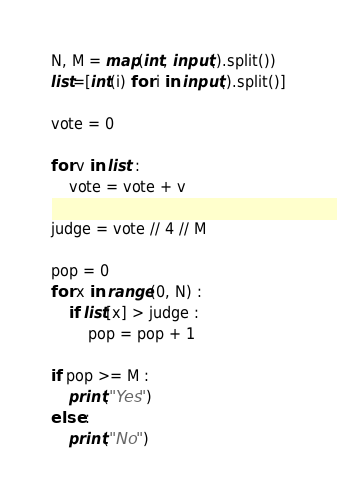<code> <loc_0><loc_0><loc_500><loc_500><_Python_>N, M = map(int, input().split())
list=[int(i) for i in input().split()]

vote = 0

for v in list :
    vote = vote + v

judge = vote // 4 // M

pop = 0
for x in range(0, N) :
    if list[x] > judge :
        pop = pop + 1

if pop >= M :
    print("Yes")
else :
    print("No")
</code> 